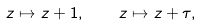Convert formula to latex. <formula><loc_0><loc_0><loc_500><loc_500>z \mapsto z + 1 , \quad z \mapsto z + \tau ,</formula> 